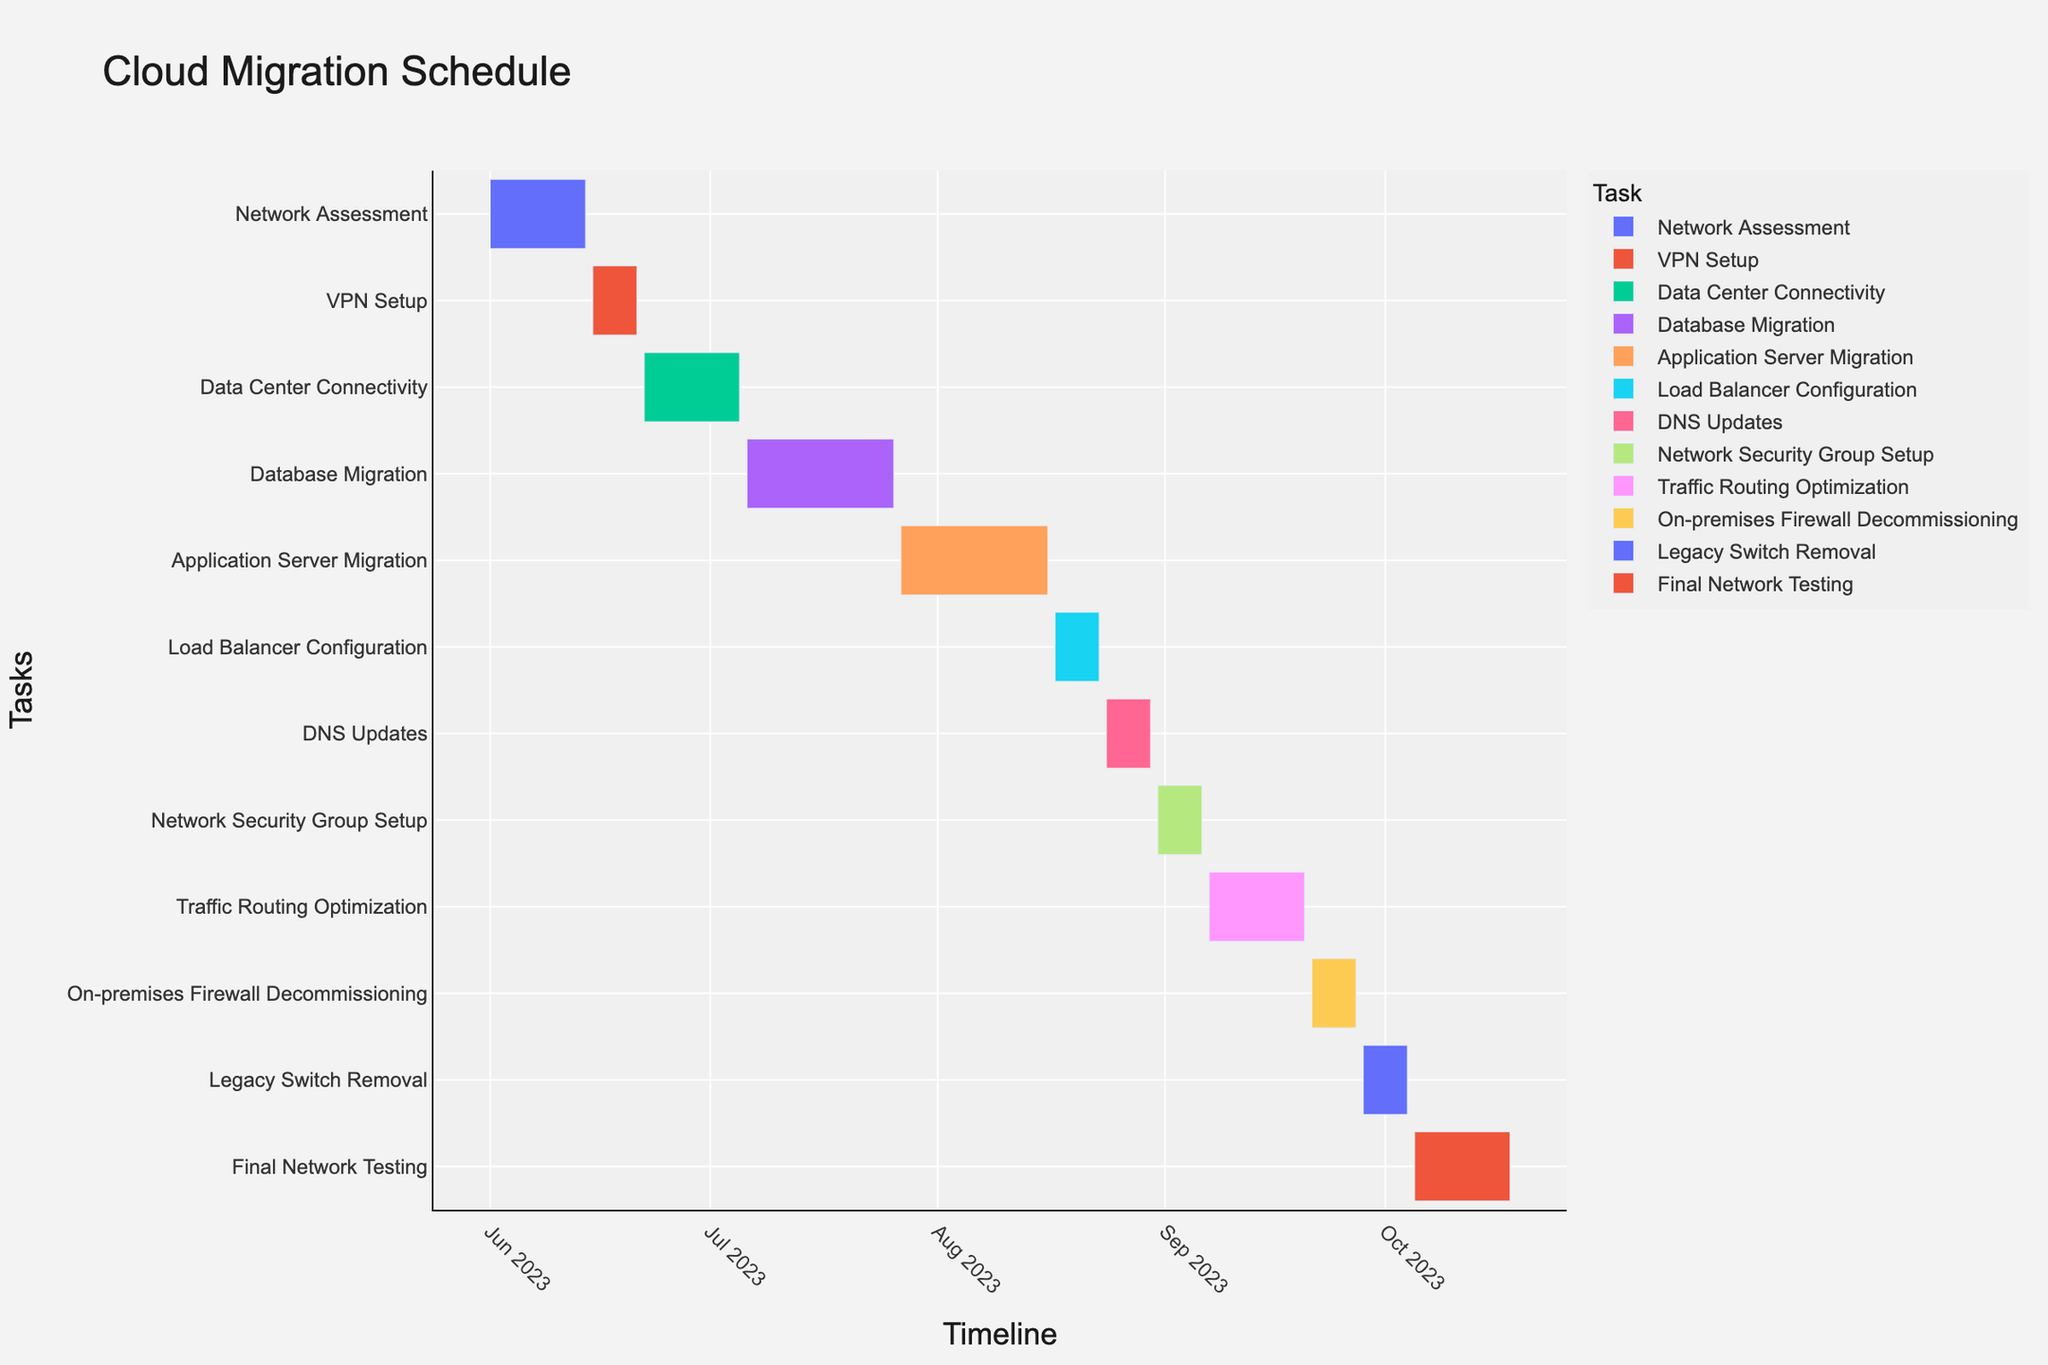what is the title of the Gantt chart? Look at the top of the chart where the title is placed; it is the most prominent text.
Answer: Cloud Migration Schedule When does the Database Migration task start and end? Refer to the horizontal bar labeled "Database Migration" to find the start and end dates at its edges.
Answer: Start: 2023-07-06, End: 2023-07-26 Which task lasts the longest, and what is its duration? Compare the lengths of all horizontal bars; the longest corresponds to the task with the longest duration, and the Duration column indicates the length in days.
Answer: Database Migration, 21 days Are there any tasks scheduled for exactly 7 days, and if so, which ones? Look for tasks whose bars span exactly 7 days as indicated in the Duration column.
Answer: VPN Setup, Load Balancer Configuration, DNS Updates, Network Security Group Setup, On-premises Firewall Decommissioning, Legacy Switch Removal What's the total duration in days for all tasks labeled under "Network" tasks? Sum the durations for tasks that contain "Network" in their label, as provided in the Duration column.
Answer: Network Assessment (14), Network Security Group Setup (7), Traffic Routing Optimization (14), Final Network Testing (14) = 49 days Which tasks overlap with the Database Migration task, and how can you tell? Identify horizontal bars that coincide with the timeframe of the Database Migration task (2023-07-06 to 2023-07-26).
Answer: Application Server Migration (2023-07-27 overlaps slightly), no direct overlap provided in given data What's the shortest task, and how does it compare to the longest task? Find the shortest bar length (indicated by the shortest duration), compare it with the longest bar to understand the difference.
Answer: Tasks with 7 days duration (shortest), Database Migration with 21 days (longest), difference is 14 days If you start the entire migration process on June 1st and finish on October 18th, what’s the total duration of the entire project? Calculate the time span from the start of the first task to the end of the last task.
Answer: June 1st to October 18th is 140 days Which task starts immediately after the Load Balancer Configuration ends, and when does it start? Look for the task that begins at the end of the Load Balancer Configuration's end date (2023-08-23).
Answer: DNS Updates, starts on 2023-08-24 If each task could be delayed by 3 days, which phase would complete last, and by what final date? Add 3 days to both start and end of each task, look at the end date of the last task.
Answer: Final Network Testing would end last, on 2023-10-21 